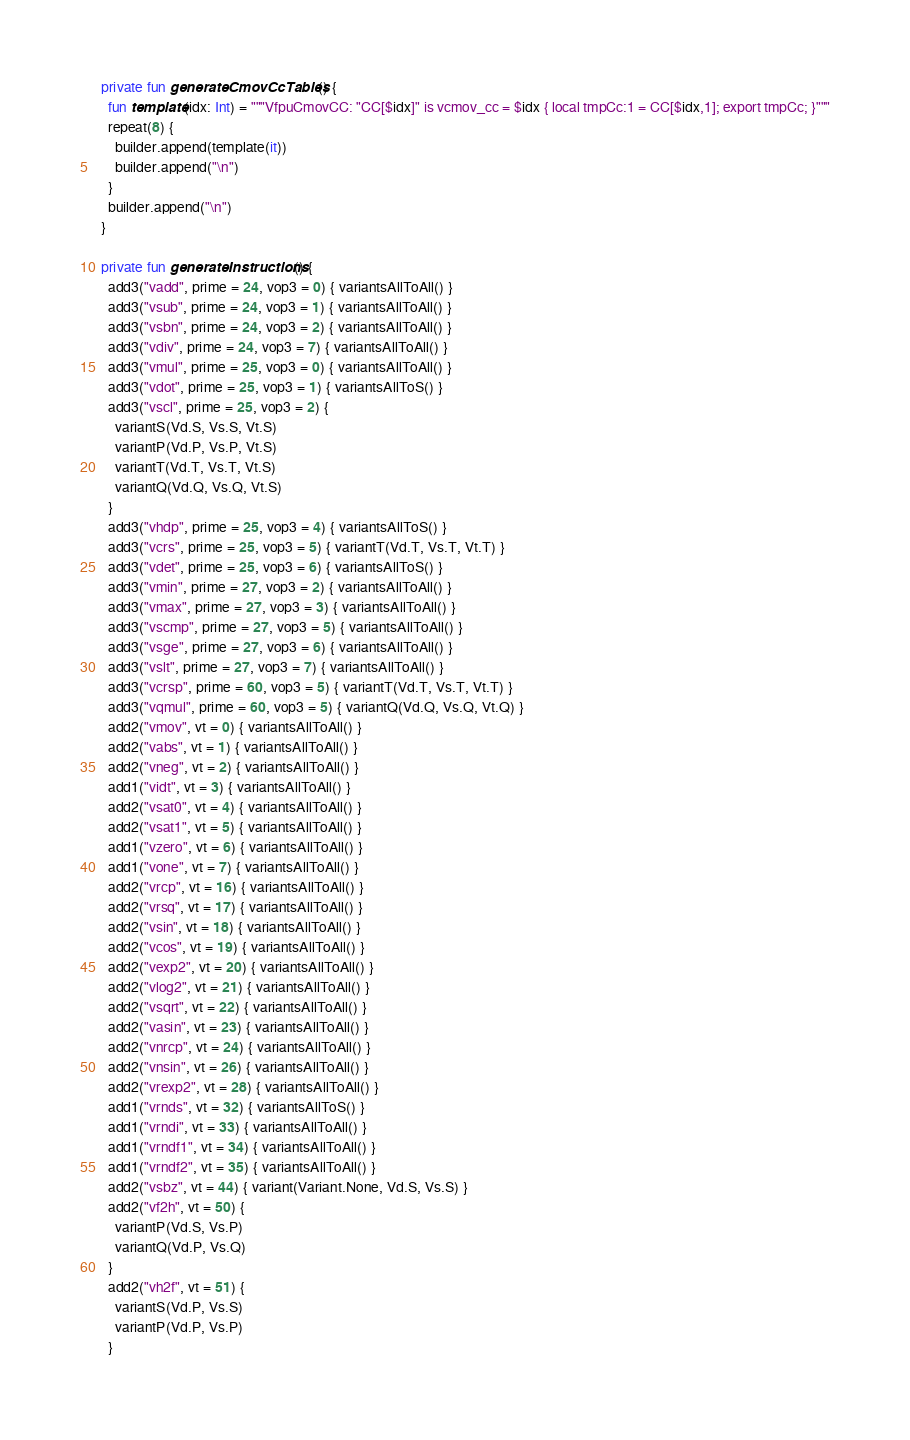Convert code to text. <code><loc_0><loc_0><loc_500><loc_500><_Kotlin_>
  private fun generateCmovCcTables() {
    fun template(idx: Int) = """VfpuCmovCC: "CC[$idx]" is vcmov_cc = $idx { local tmpCc:1 = CC[$idx,1]; export tmpCc; }"""
    repeat(8) {
      builder.append(template(it))
      builder.append("\n")
    }
    builder.append("\n")
  }

  private fun generateInstructions() {
    add3("vadd", prime = 24, vop3 = 0) { variantsAllToAll() }
    add3("vsub", prime = 24, vop3 = 1) { variantsAllToAll() }
    add3("vsbn", prime = 24, vop3 = 2) { variantsAllToAll() }
    add3("vdiv", prime = 24, vop3 = 7) { variantsAllToAll() }
    add3("vmul", prime = 25, vop3 = 0) { variantsAllToAll() }
    add3("vdot", prime = 25, vop3 = 1) { variantsAllToS() }
    add3("vscl", prime = 25, vop3 = 2) {
      variantS(Vd.S, Vs.S, Vt.S)
      variantP(Vd.P, Vs.P, Vt.S)
      variantT(Vd.T, Vs.T, Vt.S)
      variantQ(Vd.Q, Vs.Q, Vt.S)
    }
    add3("vhdp", prime = 25, vop3 = 4) { variantsAllToS() }
    add3("vcrs", prime = 25, vop3 = 5) { variantT(Vd.T, Vs.T, Vt.T) }
    add3("vdet", prime = 25, vop3 = 6) { variantsAllToS() }
    add3("vmin", prime = 27, vop3 = 2) { variantsAllToAll() }
    add3("vmax", prime = 27, vop3 = 3) { variantsAllToAll() }
    add3("vscmp", prime = 27, vop3 = 5) { variantsAllToAll() }
    add3("vsge", prime = 27, vop3 = 6) { variantsAllToAll() }
    add3("vslt", prime = 27, vop3 = 7) { variantsAllToAll() }
    add3("vcrsp", prime = 60, vop3 = 5) { variantT(Vd.T, Vs.T, Vt.T) }
    add3("vqmul", prime = 60, vop3 = 5) { variantQ(Vd.Q, Vs.Q, Vt.Q) }
    add2("vmov", vt = 0) { variantsAllToAll() }
    add2("vabs", vt = 1) { variantsAllToAll() }
    add2("vneg", vt = 2) { variantsAllToAll() }
    add1("vidt", vt = 3) { variantsAllToAll() }
    add2("vsat0", vt = 4) { variantsAllToAll() }
    add2("vsat1", vt = 5) { variantsAllToAll() }
    add1("vzero", vt = 6) { variantsAllToAll() }
    add1("vone", vt = 7) { variantsAllToAll() }
    add2("vrcp", vt = 16) { variantsAllToAll() }
    add2("vrsq", vt = 17) { variantsAllToAll() }
    add2("vsin", vt = 18) { variantsAllToAll() }
    add2("vcos", vt = 19) { variantsAllToAll() }
    add2("vexp2", vt = 20) { variantsAllToAll() }
    add2("vlog2", vt = 21) { variantsAllToAll() }
    add2("vsqrt", vt = 22) { variantsAllToAll() }
    add2("vasin", vt = 23) { variantsAllToAll() }
    add2("vnrcp", vt = 24) { variantsAllToAll() }
    add2("vnsin", vt = 26) { variantsAllToAll() }
    add2("vrexp2", vt = 28) { variantsAllToAll() }
    add1("vrnds", vt = 32) { variantsAllToS() }
    add1("vrndi", vt = 33) { variantsAllToAll() }
    add1("vrndf1", vt = 34) { variantsAllToAll() }
    add1("vrndf2", vt = 35) { variantsAllToAll() }
    add2("vsbz", vt = 44) { variant(Variant.None, Vd.S, Vs.S) }
    add2("vf2h", vt = 50) {
      variantP(Vd.S, Vs.P)
      variantQ(Vd.P, Vs.Q)
    }
    add2("vh2f", vt = 51) {
      variantS(Vd.P, Vs.S)
      variantP(Vd.P, Vs.P)
    }</code> 